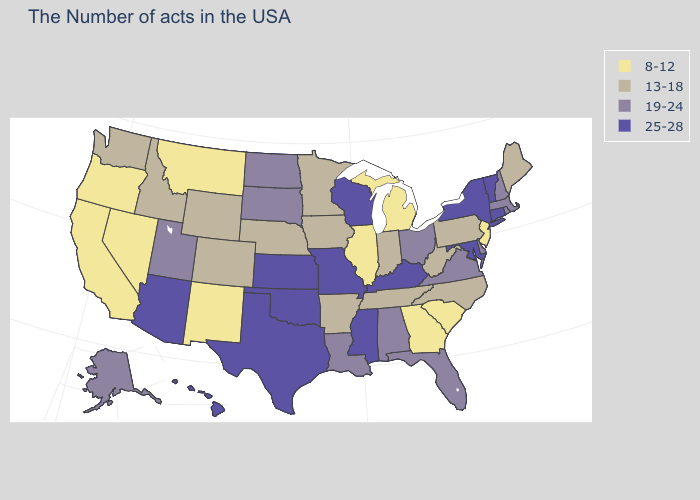Name the states that have a value in the range 8-12?
Be succinct. New Jersey, South Carolina, Georgia, Michigan, Illinois, New Mexico, Montana, Nevada, California, Oregon. Does Alaska have a higher value than California?
Concise answer only. Yes. What is the value of Tennessee?
Write a very short answer. 13-18. Is the legend a continuous bar?
Be succinct. No. What is the lowest value in states that border North Carolina?
Quick response, please. 8-12. Does the map have missing data?
Answer briefly. No. Among the states that border Pennsylvania , does Ohio have the highest value?
Keep it brief. No. Is the legend a continuous bar?
Short answer required. No. Name the states that have a value in the range 19-24?
Write a very short answer. Massachusetts, Rhode Island, New Hampshire, Delaware, Virginia, Ohio, Florida, Alabama, Louisiana, South Dakota, North Dakota, Utah, Alaska. Does Florida have the lowest value in the South?
Concise answer only. No. What is the value of Nevada?
Short answer required. 8-12. What is the lowest value in the USA?
Concise answer only. 8-12. Does Maine have the highest value in the Northeast?
Answer briefly. No. Which states have the highest value in the USA?
Keep it brief. Vermont, Connecticut, New York, Maryland, Kentucky, Wisconsin, Mississippi, Missouri, Kansas, Oklahoma, Texas, Arizona, Hawaii. 